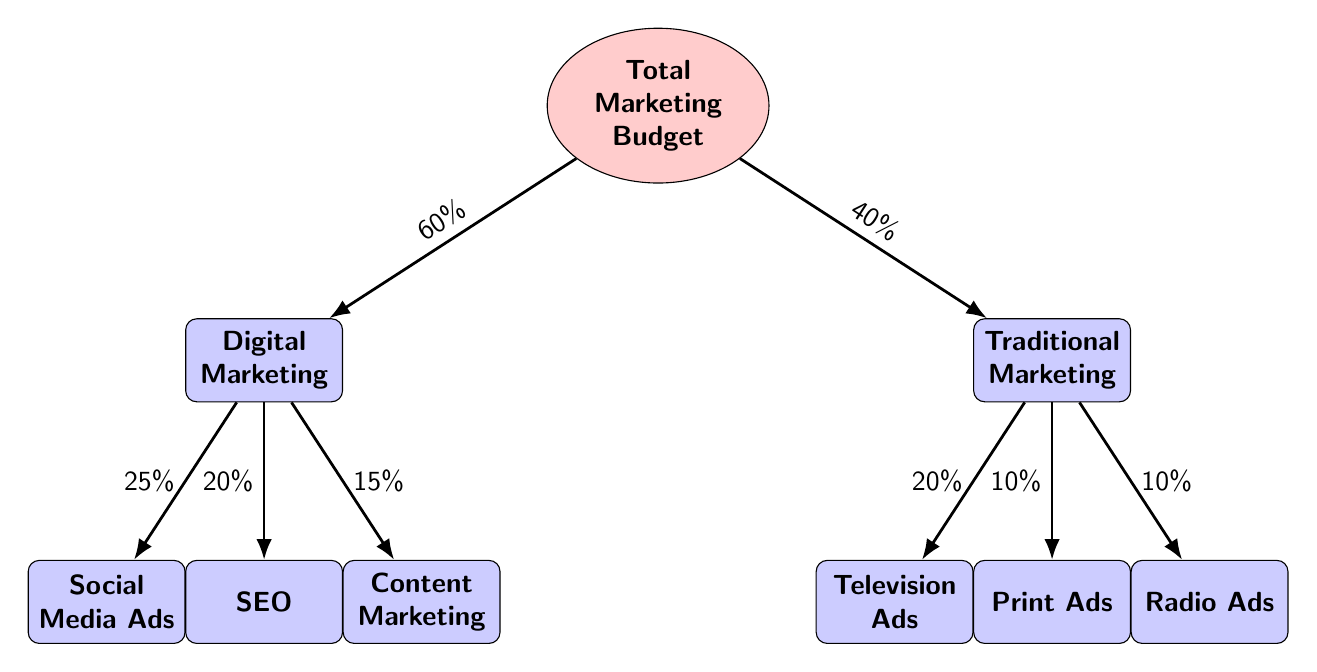What percentage of the total marketing budget is allocated to digital marketing? The total marketing budget is divided between digital and traditional marketing, with digital marketing being allocated 60% of the total budget as indicated by the arrow from the total budget node to the digital marketing node.
Answer: 60% What is the total number of marketing channels represented in the diagram? The diagram includes four channels under digital marketing (social media ads, SEO, content marketing) and three channels under traditional marketing (television ads, print ads, radio ads), leading to a total of seven channels in total.
Answer: 7 What is the percentage allocated to SEO within digital marketing? The node for SEO, located under digital marketing, shows an allocation of 20%, which is indicated by the line connecting it to the digital marketing node.
Answer: 20% Which marketing channel has the least budget allocation? By reviewing all channels, print ads and radio ads both have an allocation of 10%, making them the channels with the least budget allocation compared to others, which have higher percentages.
Answer: Print Ads or Radio Ads What is the combined percentage allocation of all social media ads and content marketing in the digital marketing budget? Social media ads have a budget allocation of 25% and content marketing has an allocation of 15%. Adding these two percentages together gives a total of 40% allocated to these channels.
Answer: 40% What is the relationship between digital and traditional marketing budgets in terms of percentage? The diagram illustrates that digital marketing receives 60% of the total budget while traditional marketing is allocated 40%. This clearly shows that the digital marketing budget is larger by 20%.
Answer: Digital marketing is larger by 20% Which traditional marketing channel receives the highest percentage of the budget? Looking at the traditional marketing channels, television ads have the highest allocation at 20%, surpassing print ads (10%) and radio ads (10%).
Answer: Television Ads 